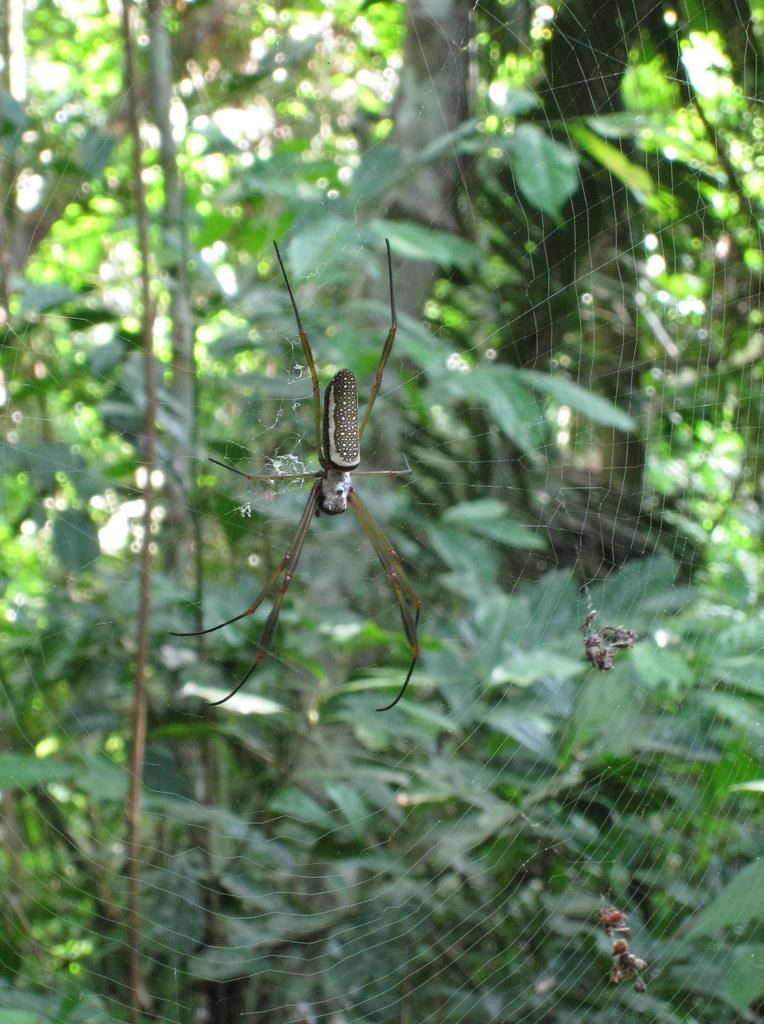What is located in the center of the image? There is a spider web in the center of the image. What can be seen in the background of the image? There are trees visible in the background of the image. What type of operation is being performed on the bears in the image? There are no bears or any indication of an operation in the image; it features a spider web and trees in the background. 